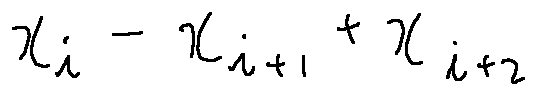Convert formula to latex. <formula><loc_0><loc_0><loc_500><loc_500>x _ { i } - x _ { i + 1 } + x _ { i + 2 }</formula> 